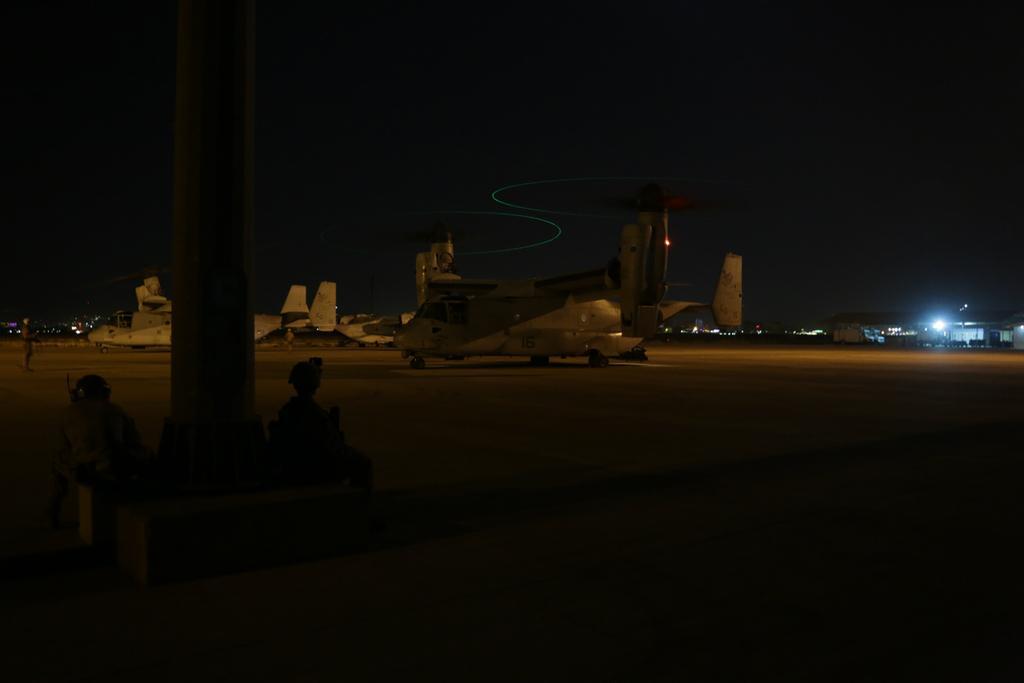How would you summarize this image in a sentence or two? In this picture, we see airplanes and some vehicles on the runway. There are many buildings and lights in the background and this picture is clicked in the dark. 